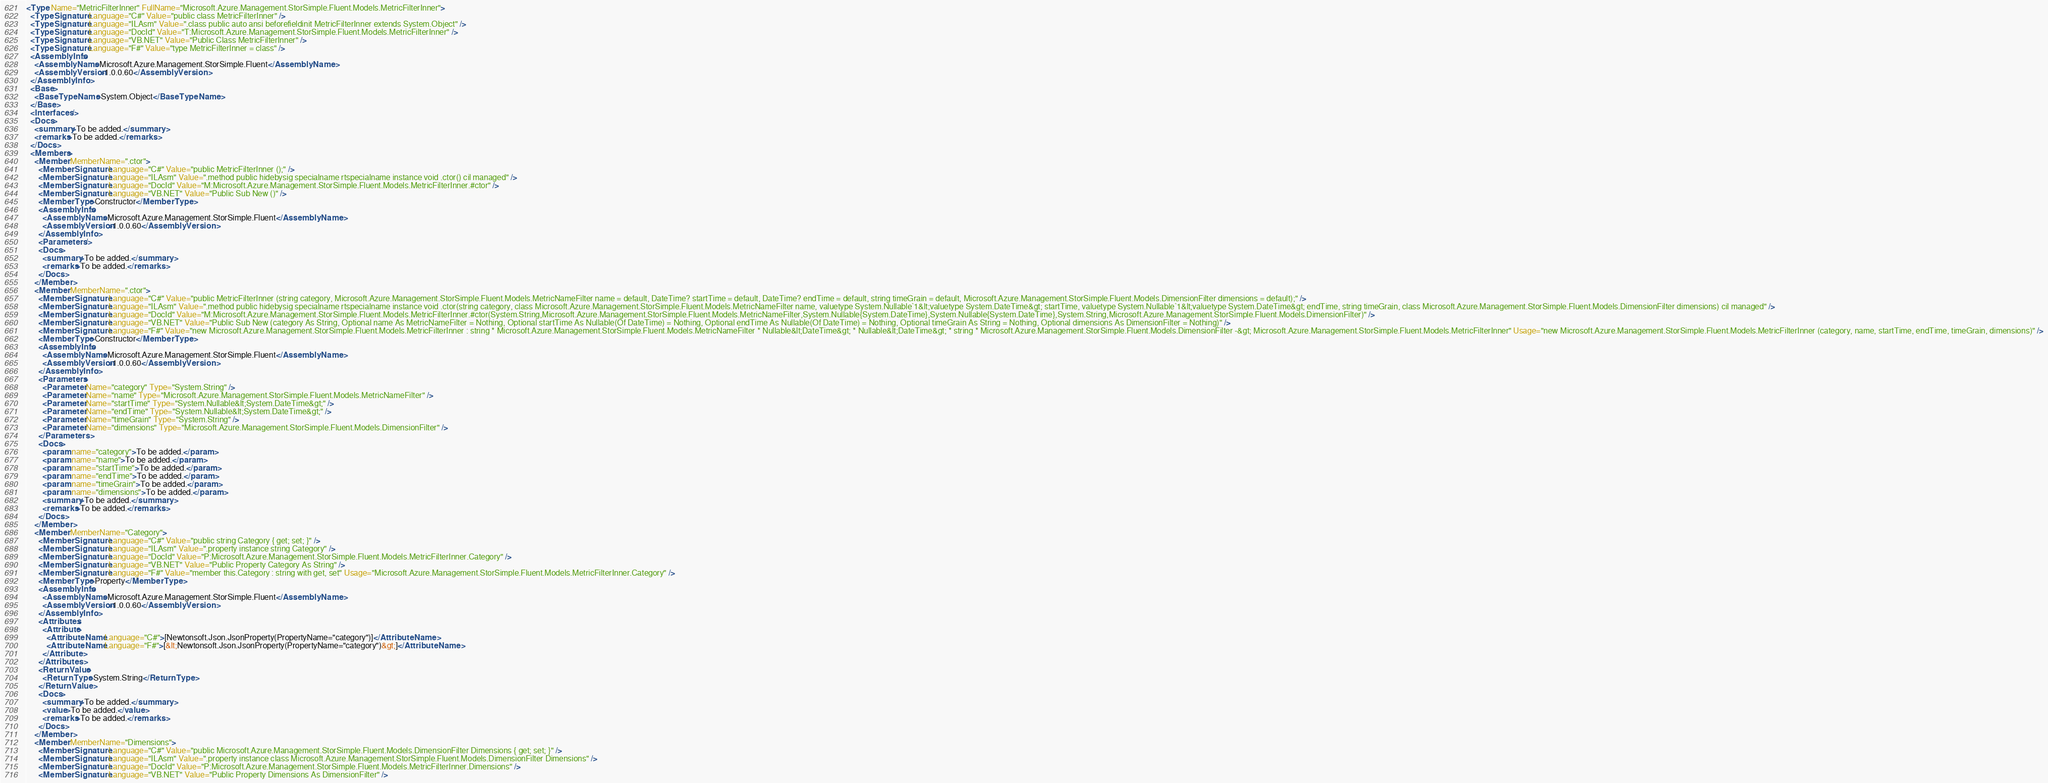<code> <loc_0><loc_0><loc_500><loc_500><_XML_><Type Name="MetricFilterInner" FullName="Microsoft.Azure.Management.StorSimple.Fluent.Models.MetricFilterInner">
  <TypeSignature Language="C#" Value="public class MetricFilterInner" />
  <TypeSignature Language="ILAsm" Value=".class public auto ansi beforefieldinit MetricFilterInner extends System.Object" />
  <TypeSignature Language="DocId" Value="T:Microsoft.Azure.Management.StorSimple.Fluent.Models.MetricFilterInner" />
  <TypeSignature Language="VB.NET" Value="Public Class MetricFilterInner" />
  <TypeSignature Language="F#" Value="type MetricFilterInner = class" />
  <AssemblyInfo>
    <AssemblyName>Microsoft.Azure.Management.StorSimple.Fluent</AssemblyName>
    <AssemblyVersion>1.0.0.60</AssemblyVersion>
  </AssemblyInfo>
  <Base>
    <BaseTypeName>System.Object</BaseTypeName>
  </Base>
  <Interfaces />
  <Docs>
    <summary>To be added.</summary>
    <remarks>To be added.</remarks>
  </Docs>
  <Members>
    <Member MemberName=".ctor">
      <MemberSignature Language="C#" Value="public MetricFilterInner ();" />
      <MemberSignature Language="ILAsm" Value=".method public hidebysig specialname rtspecialname instance void .ctor() cil managed" />
      <MemberSignature Language="DocId" Value="M:Microsoft.Azure.Management.StorSimple.Fluent.Models.MetricFilterInner.#ctor" />
      <MemberSignature Language="VB.NET" Value="Public Sub New ()" />
      <MemberType>Constructor</MemberType>
      <AssemblyInfo>
        <AssemblyName>Microsoft.Azure.Management.StorSimple.Fluent</AssemblyName>
        <AssemblyVersion>1.0.0.60</AssemblyVersion>
      </AssemblyInfo>
      <Parameters />
      <Docs>
        <summary>To be added.</summary>
        <remarks>To be added.</remarks>
      </Docs>
    </Member>
    <Member MemberName=".ctor">
      <MemberSignature Language="C#" Value="public MetricFilterInner (string category, Microsoft.Azure.Management.StorSimple.Fluent.Models.MetricNameFilter name = default, DateTime? startTime = default, DateTime? endTime = default, string timeGrain = default, Microsoft.Azure.Management.StorSimple.Fluent.Models.DimensionFilter dimensions = default);" />
      <MemberSignature Language="ILAsm" Value=".method public hidebysig specialname rtspecialname instance void .ctor(string category, class Microsoft.Azure.Management.StorSimple.Fluent.Models.MetricNameFilter name, valuetype System.Nullable`1&lt;valuetype System.DateTime&gt; startTime, valuetype System.Nullable`1&lt;valuetype System.DateTime&gt; endTime, string timeGrain, class Microsoft.Azure.Management.StorSimple.Fluent.Models.DimensionFilter dimensions) cil managed" />
      <MemberSignature Language="DocId" Value="M:Microsoft.Azure.Management.StorSimple.Fluent.Models.MetricFilterInner.#ctor(System.String,Microsoft.Azure.Management.StorSimple.Fluent.Models.MetricNameFilter,System.Nullable{System.DateTime},System.Nullable{System.DateTime},System.String,Microsoft.Azure.Management.StorSimple.Fluent.Models.DimensionFilter)" />
      <MemberSignature Language="VB.NET" Value="Public Sub New (category As String, Optional name As MetricNameFilter = Nothing, Optional startTime As Nullable(Of DateTime) = Nothing, Optional endTime As Nullable(Of DateTime) = Nothing, Optional timeGrain As String = Nothing, Optional dimensions As DimensionFilter = Nothing)" />
      <MemberSignature Language="F#" Value="new Microsoft.Azure.Management.StorSimple.Fluent.Models.MetricFilterInner : string * Microsoft.Azure.Management.StorSimple.Fluent.Models.MetricNameFilter * Nullable&lt;DateTime&gt; * Nullable&lt;DateTime&gt; * string * Microsoft.Azure.Management.StorSimple.Fluent.Models.DimensionFilter -&gt; Microsoft.Azure.Management.StorSimple.Fluent.Models.MetricFilterInner" Usage="new Microsoft.Azure.Management.StorSimple.Fluent.Models.MetricFilterInner (category, name, startTime, endTime, timeGrain, dimensions)" />
      <MemberType>Constructor</MemberType>
      <AssemblyInfo>
        <AssemblyName>Microsoft.Azure.Management.StorSimple.Fluent</AssemblyName>
        <AssemblyVersion>1.0.0.60</AssemblyVersion>
      </AssemblyInfo>
      <Parameters>
        <Parameter Name="category" Type="System.String" />
        <Parameter Name="name" Type="Microsoft.Azure.Management.StorSimple.Fluent.Models.MetricNameFilter" />
        <Parameter Name="startTime" Type="System.Nullable&lt;System.DateTime&gt;" />
        <Parameter Name="endTime" Type="System.Nullable&lt;System.DateTime&gt;" />
        <Parameter Name="timeGrain" Type="System.String" />
        <Parameter Name="dimensions" Type="Microsoft.Azure.Management.StorSimple.Fluent.Models.DimensionFilter" />
      </Parameters>
      <Docs>
        <param name="category">To be added.</param>
        <param name="name">To be added.</param>
        <param name="startTime">To be added.</param>
        <param name="endTime">To be added.</param>
        <param name="timeGrain">To be added.</param>
        <param name="dimensions">To be added.</param>
        <summary>To be added.</summary>
        <remarks>To be added.</remarks>
      </Docs>
    </Member>
    <Member MemberName="Category">
      <MemberSignature Language="C#" Value="public string Category { get; set; }" />
      <MemberSignature Language="ILAsm" Value=".property instance string Category" />
      <MemberSignature Language="DocId" Value="P:Microsoft.Azure.Management.StorSimple.Fluent.Models.MetricFilterInner.Category" />
      <MemberSignature Language="VB.NET" Value="Public Property Category As String" />
      <MemberSignature Language="F#" Value="member this.Category : string with get, set" Usage="Microsoft.Azure.Management.StorSimple.Fluent.Models.MetricFilterInner.Category" />
      <MemberType>Property</MemberType>
      <AssemblyInfo>
        <AssemblyName>Microsoft.Azure.Management.StorSimple.Fluent</AssemblyName>
        <AssemblyVersion>1.0.0.60</AssemblyVersion>
      </AssemblyInfo>
      <Attributes>
        <Attribute>
          <AttributeName Language="C#">[Newtonsoft.Json.JsonProperty(PropertyName="category")]</AttributeName>
          <AttributeName Language="F#">[&lt;Newtonsoft.Json.JsonProperty(PropertyName="category")&gt;]</AttributeName>
        </Attribute>
      </Attributes>
      <ReturnValue>
        <ReturnType>System.String</ReturnType>
      </ReturnValue>
      <Docs>
        <summary>To be added.</summary>
        <value>To be added.</value>
        <remarks>To be added.</remarks>
      </Docs>
    </Member>
    <Member MemberName="Dimensions">
      <MemberSignature Language="C#" Value="public Microsoft.Azure.Management.StorSimple.Fluent.Models.DimensionFilter Dimensions { get; set; }" />
      <MemberSignature Language="ILAsm" Value=".property instance class Microsoft.Azure.Management.StorSimple.Fluent.Models.DimensionFilter Dimensions" />
      <MemberSignature Language="DocId" Value="P:Microsoft.Azure.Management.StorSimple.Fluent.Models.MetricFilterInner.Dimensions" />
      <MemberSignature Language="VB.NET" Value="Public Property Dimensions As DimensionFilter" /></code> 